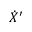Convert formula to latex. <formula><loc_0><loc_0><loc_500><loc_500>{ \dot { X } } ^ { \prime }</formula> 